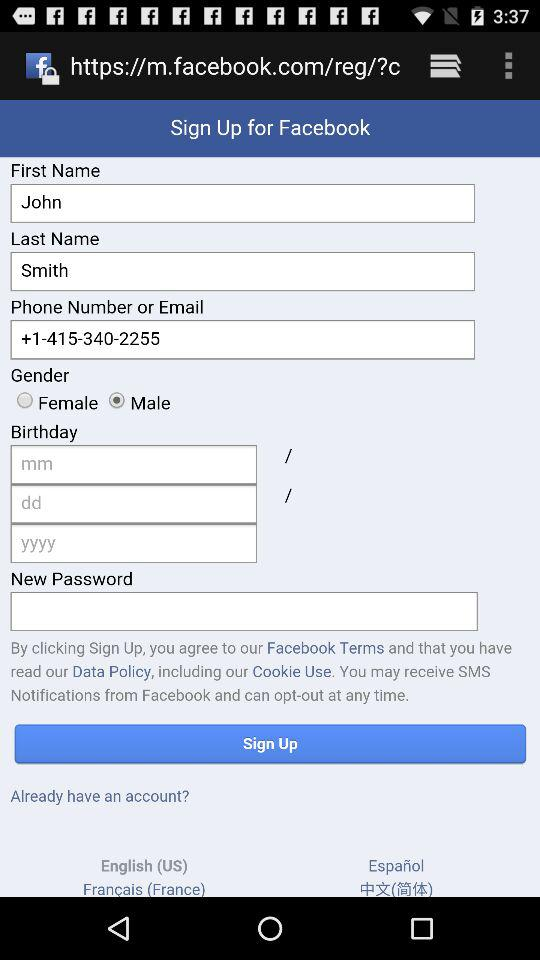What is the selected gender? The selected gender is male. 